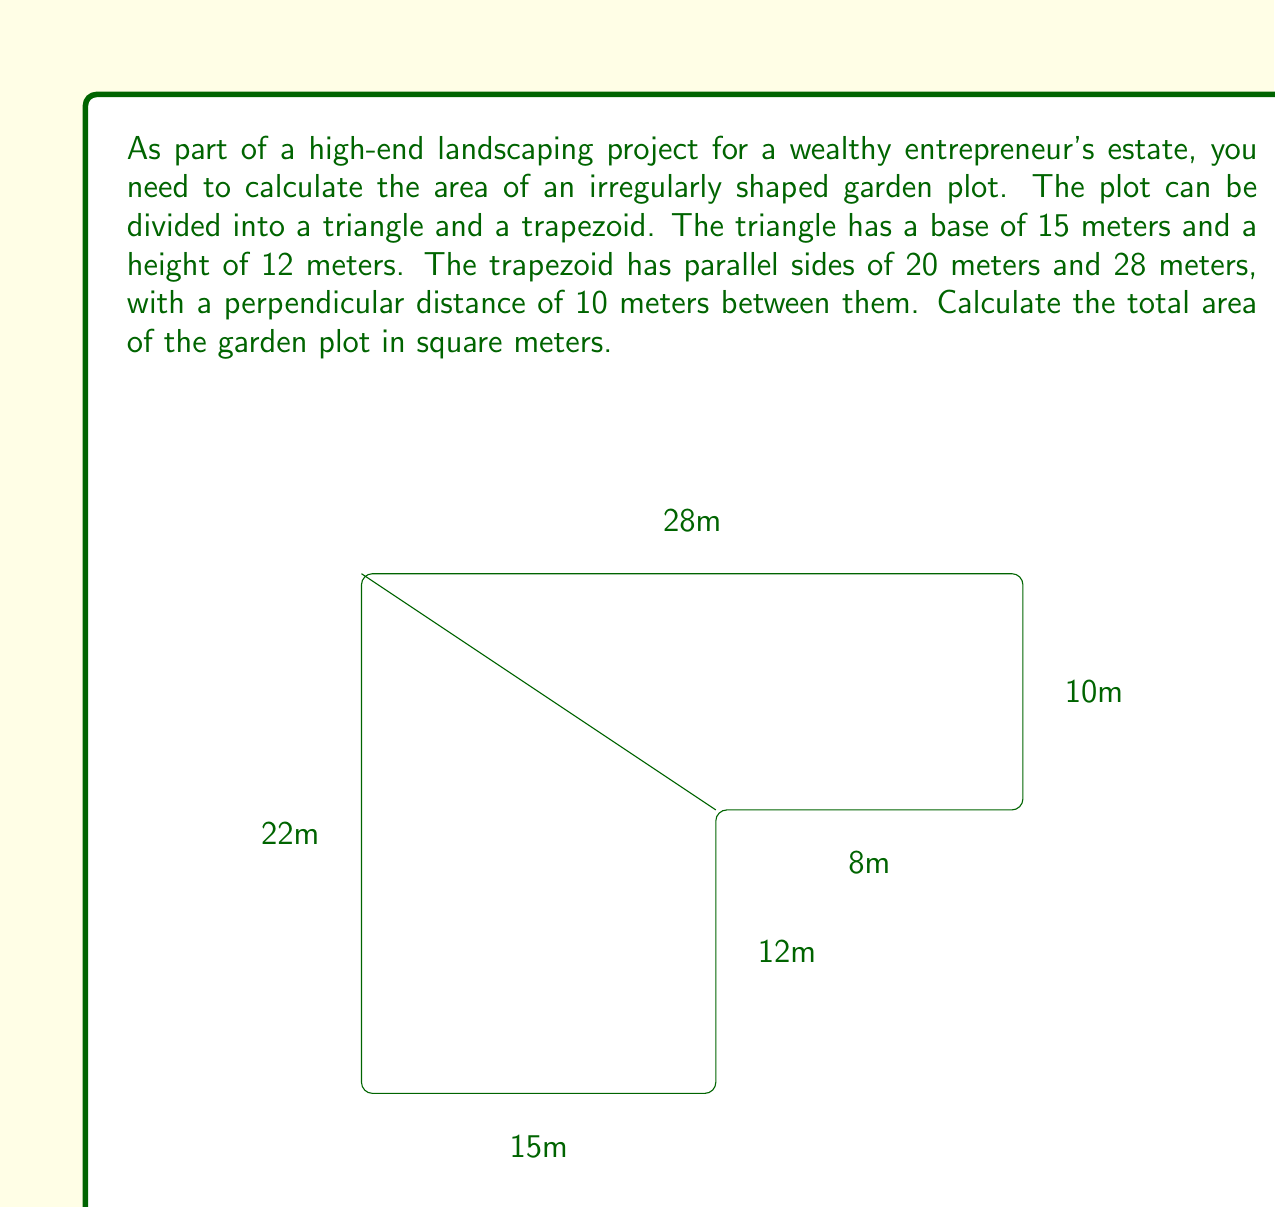Teach me how to tackle this problem. To solve this problem, we'll calculate the areas of the triangle and trapezoid separately, then add them together.

1. Area of the triangle:
   The formula for the area of a triangle is $A = \frac{1}{2} \times base \times height$
   $$A_{triangle} = \frac{1}{2} \times 15 \times 12 = 90 \text{ m}^2$$

2. Area of the trapezoid:
   The formula for the area of a trapezoid is $A = \frac{1}{2}(a+b)h$, where $a$ and $b$ are the parallel sides and $h$ is the height.
   $$A_{trapezoid} = \frac{1}{2}(20+28) \times 10 = 240 \text{ m}^2$$

3. Total area:
   To get the total area, we add the areas of the triangle and trapezoid:
   $$A_{total} = A_{triangle} + A_{trapezoid} = 90 + 240 = 330 \text{ m}^2$$

Therefore, the total area of the irregularly shaped garden plot is 330 square meters.
Answer: 330 m² 